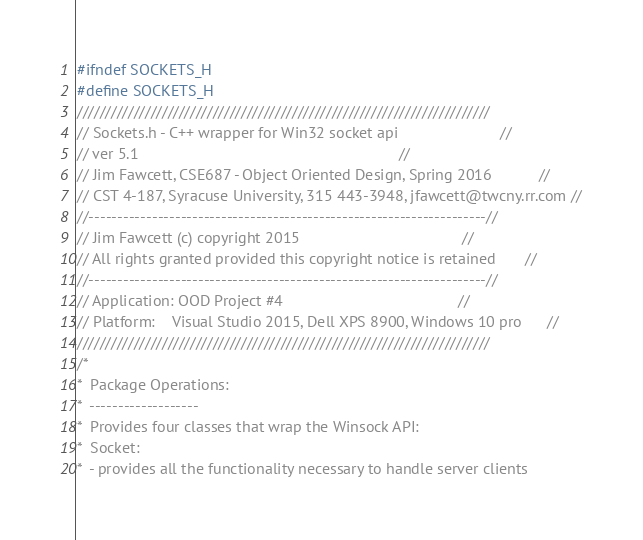Convert code to text. <code><loc_0><loc_0><loc_500><loc_500><_C_>#ifndef SOCKETS_H
#define SOCKETS_H
/////////////////////////////////////////////////////////////////////////
// Sockets.h - C++ wrapper for Win32 socket api                        //
// ver 5.1                                                             //
// Jim Fawcett, CSE687 - Object Oriented Design, Spring 2016           //
// CST 4-187, Syracuse University, 315 443-3948, jfawcett@twcny.rr.com //
//---------------------------------------------------------------------//
// Jim Fawcett (c) copyright 2015                                      //
// All rights granted provided this copyright notice is retained       //
//---------------------------------------------------------------------//
// Application: OOD Project #4                                         //
// Platform:    Visual Studio 2015, Dell XPS 8900, Windows 10 pro      //
/////////////////////////////////////////////////////////////////////////
/*
*  Package Operations:
*  -------------------
*  Provides four classes that wrap the Winsock API:
*  Socket:
*  - provides all the functionality necessary to handle server clients</code> 